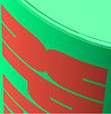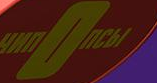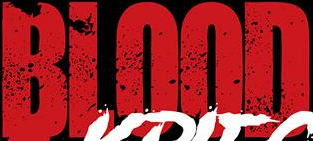What text appears in these images from left to right, separated by a semicolon? dk; nOnCbI; BLOOD 